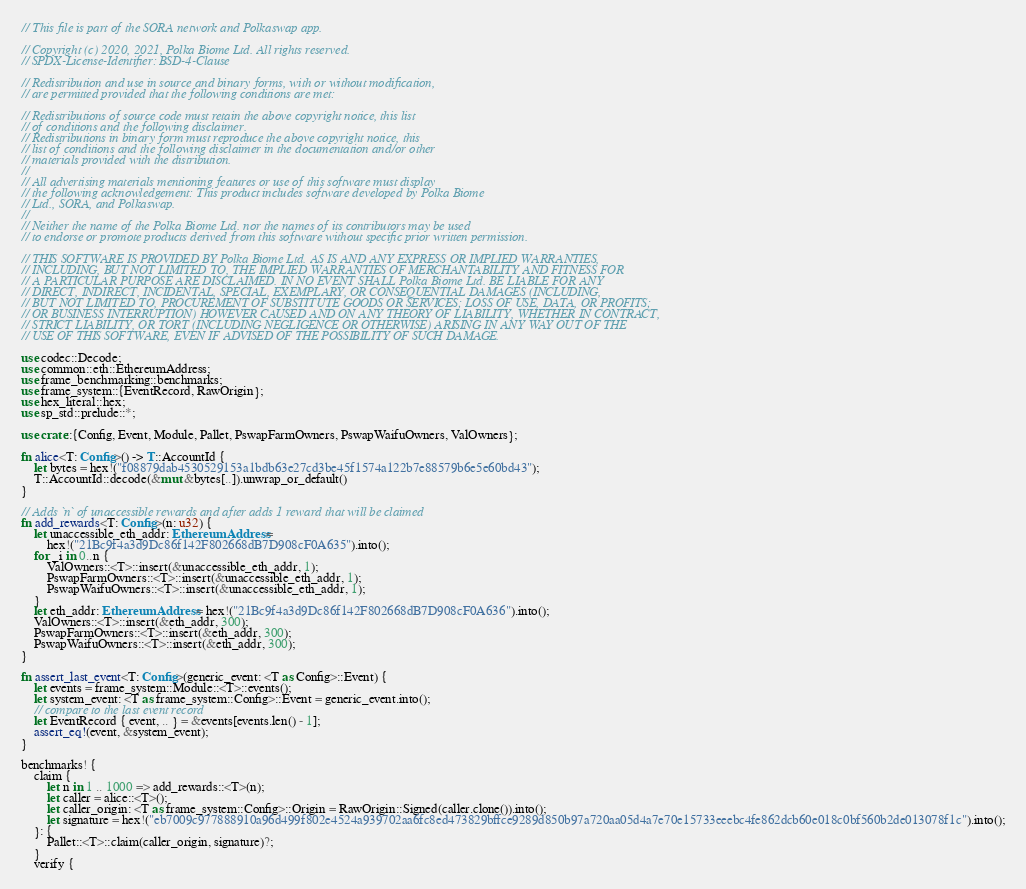<code> <loc_0><loc_0><loc_500><loc_500><_Rust_>// This file is part of the SORA network and Polkaswap app.

// Copyright (c) 2020, 2021, Polka Biome Ltd. All rights reserved.
// SPDX-License-Identifier: BSD-4-Clause

// Redistribution and use in source and binary forms, with or without modification,
// are permitted provided that the following conditions are met:

// Redistributions of source code must retain the above copyright notice, this list
// of conditions and the following disclaimer.
// Redistributions in binary form must reproduce the above copyright notice, this
// list of conditions and the following disclaimer in the documentation and/or other
// materials provided with the distribution.
//
// All advertising materials mentioning features or use of this software must display
// the following acknowledgement: This product includes software developed by Polka Biome
// Ltd., SORA, and Polkaswap.
//
// Neither the name of the Polka Biome Ltd. nor the names of its contributors may be used
// to endorse or promote products derived from this software without specific prior written permission.

// THIS SOFTWARE IS PROVIDED BY Polka Biome Ltd. AS IS AND ANY EXPRESS OR IMPLIED WARRANTIES,
// INCLUDING, BUT NOT LIMITED TO, THE IMPLIED WARRANTIES OF MERCHANTABILITY AND FITNESS FOR
// A PARTICULAR PURPOSE ARE DISCLAIMED. IN NO EVENT SHALL Polka Biome Ltd. BE LIABLE FOR ANY
// DIRECT, INDIRECT, INCIDENTAL, SPECIAL, EXEMPLARY, OR CONSEQUENTIAL DAMAGES (INCLUDING,
// BUT NOT LIMITED TO, PROCUREMENT OF SUBSTITUTE GOODS OR SERVICES; LOSS OF USE, DATA, OR PROFITS;
// OR BUSINESS INTERRUPTION) HOWEVER CAUSED AND ON ANY THEORY OF LIABILITY, WHETHER IN CONTRACT,
// STRICT LIABILITY, OR TORT (INCLUDING NEGLIGENCE OR OTHERWISE) ARISING IN ANY WAY OUT OF THE
// USE OF THIS SOFTWARE, EVEN IF ADVISED OF THE POSSIBILITY OF SUCH DAMAGE.

use codec::Decode;
use common::eth::EthereumAddress;
use frame_benchmarking::benchmarks;
use frame_system::{EventRecord, RawOrigin};
use hex_literal::hex;
use sp_std::prelude::*;

use crate::{Config, Event, Module, Pallet, PswapFarmOwners, PswapWaifuOwners, ValOwners};

fn alice<T: Config>() -> T::AccountId {
    let bytes = hex!("f08879dab4530529153a1bdb63e27cd3be45f1574a122b7e88579b6e5e60bd43");
    T::AccountId::decode(&mut &bytes[..]).unwrap_or_default()
}

// Adds `n` of unaccessible rewards and after adds 1 reward that will be claimed
fn add_rewards<T: Config>(n: u32) {
    let unaccessible_eth_addr: EthereumAddress =
        hex!("21Bc9f4a3d9Dc86f142F802668dB7D908cF0A635").into();
    for _i in 0..n {
        ValOwners::<T>::insert(&unaccessible_eth_addr, 1);
        PswapFarmOwners::<T>::insert(&unaccessible_eth_addr, 1);
        PswapWaifuOwners::<T>::insert(&unaccessible_eth_addr, 1);
    }
    let eth_addr: EthereumAddress = hex!("21Bc9f4a3d9Dc86f142F802668dB7D908cF0A636").into();
    ValOwners::<T>::insert(&eth_addr, 300);
    PswapFarmOwners::<T>::insert(&eth_addr, 300);
    PswapWaifuOwners::<T>::insert(&eth_addr, 300);
}

fn assert_last_event<T: Config>(generic_event: <T as Config>::Event) {
    let events = frame_system::Module::<T>::events();
    let system_event: <T as frame_system::Config>::Event = generic_event.into();
    // compare to the last event record
    let EventRecord { event, .. } = &events[events.len() - 1];
    assert_eq!(event, &system_event);
}

benchmarks! {
    claim {
        let n in 1 .. 1000 => add_rewards::<T>(n);
        let caller = alice::<T>();
        let caller_origin: <T as frame_system::Config>::Origin = RawOrigin::Signed(caller.clone()).into();
        let signature = hex!("eb7009c977888910a96d499f802e4524a939702aa6fc8ed473829bffce9289d850b97a720aa05d4a7e70e15733eeebc4fe862dcb60e018c0bf560b2de013078f1c").into();
    }: {
        Pallet::<T>::claim(caller_origin, signature)?;
    }
    verify {</code> 